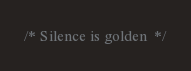<code> <loc_0><loc_0><loc_500><loc_500><_CSS_>/* Silence is golden  */
</code> 